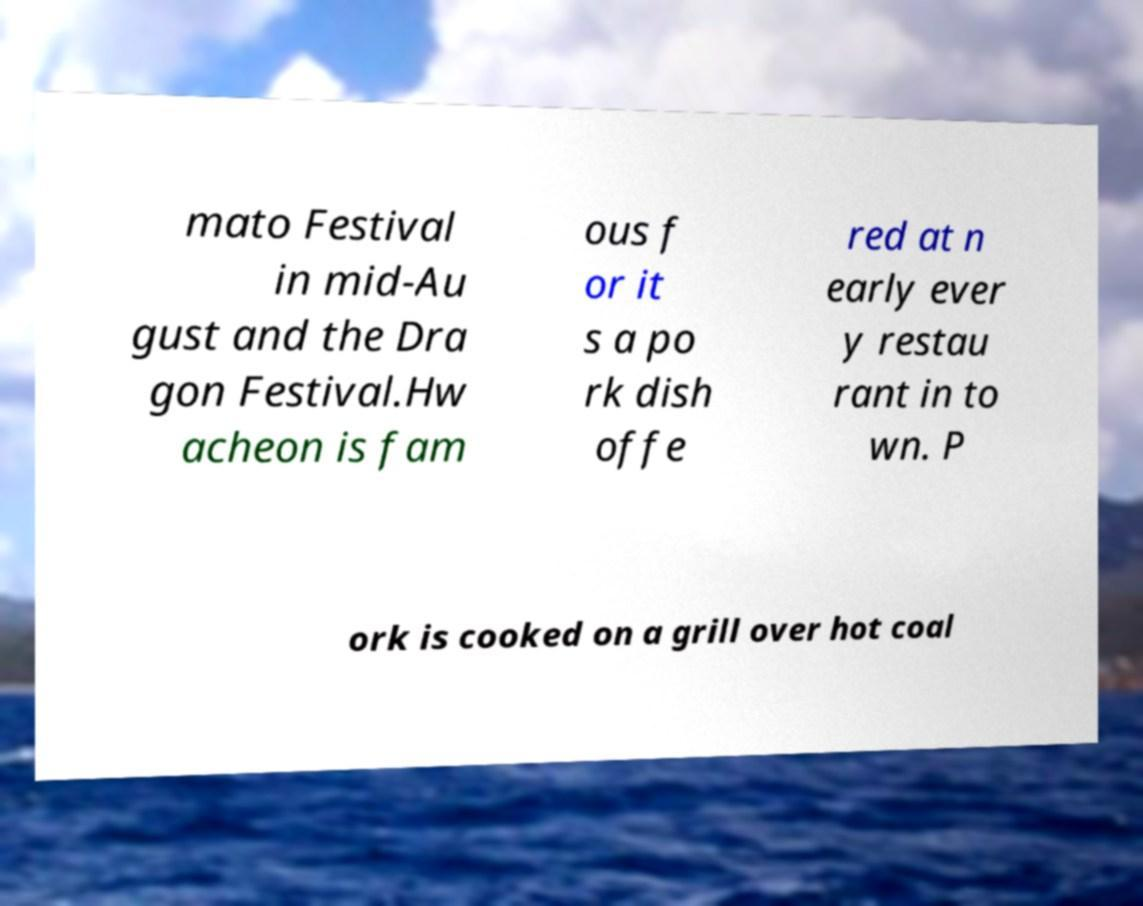For documentation purposes, I need the text within this image transcribed. Could you provide that? mato Festival in mid-Au gust and the Dra gon Festival.Hw acheon is fam ous f or it s a po rk dish offe red at n early ever y restau rant in to wn. P ork is cooked on a grill over hot coal 